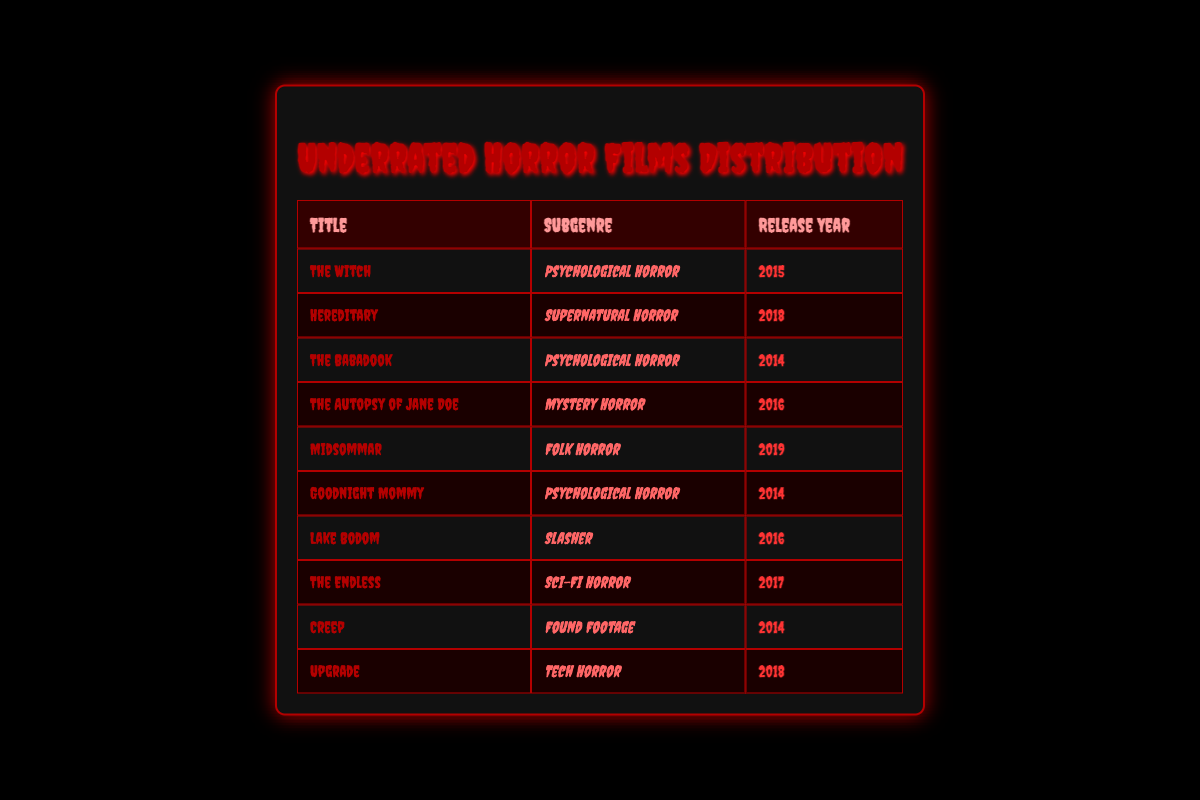What is the title of the film released in 2019? The only film released in 2019 listed in the table is "Midsommar."
Answer: Midsommar How many horror films were released in 2016? There are three films released in 2016: "The Autopsy of Jane Doe," "Lake Bodom," and "The Witch."
Answer: 3 Is "The Babadook" a psychological horror film? Yes, "The Babadook" is classified under the subgenre of psychological horror according to the table.
Answer: Yes What is the most recent horror film listed in the table? The latest release year among the films is 2019, with "Midsommar" being the only film released in that year.
Answer: Midsommar Which subgenre has the most films listed in the table? By analyzing the subgenre column, psychological horror appears three times with "The Witch," "The Babadook," and "Goodnight Mommy," making it the most represented subgenre.
Answer: Psychological Horror What is the release year of the film "Hereditary"? The table indicates that "Hereditary" was released in 2018.
Answer: 2018 How many films in the table belong to the supernatural horror subgenre? There is only one film in the supernatural horror subgenre, which is "Hereditary."
Answer: 1 Is there a horror film from the found footage subgenre that was released before 2016? Yes, "Creep," which belongs to the found footage subgenre, was released in 2014.
Answer: Yes If you were to calculate the average release year of films in the table, what would it be? The release years to consider are 2014, 2015, 2016, 2017, 2018, and 2019. The total of these years is 2014 + 2015 + 2016 + 2017 + 2018 + 2019 = 12109. There are 10 films, so the average year is 12109/10 = 2014.9, which rounds to 2015.
Answer: 2015 